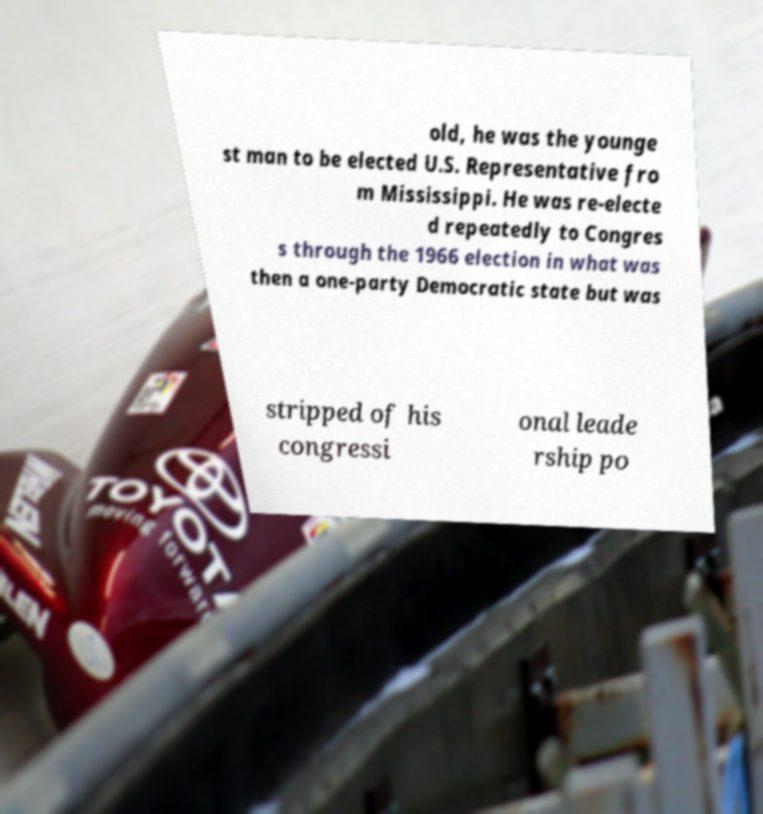Please read and relay the text visible in this image. What does it say? old, he was the younge st man to be elected U.S. Representative fro m Mississippi. He was re-electe d repeatedly to Congres s through the 1966 election in what was then a one-party Democratic state but was stripped of his congressi onal leade rship po 